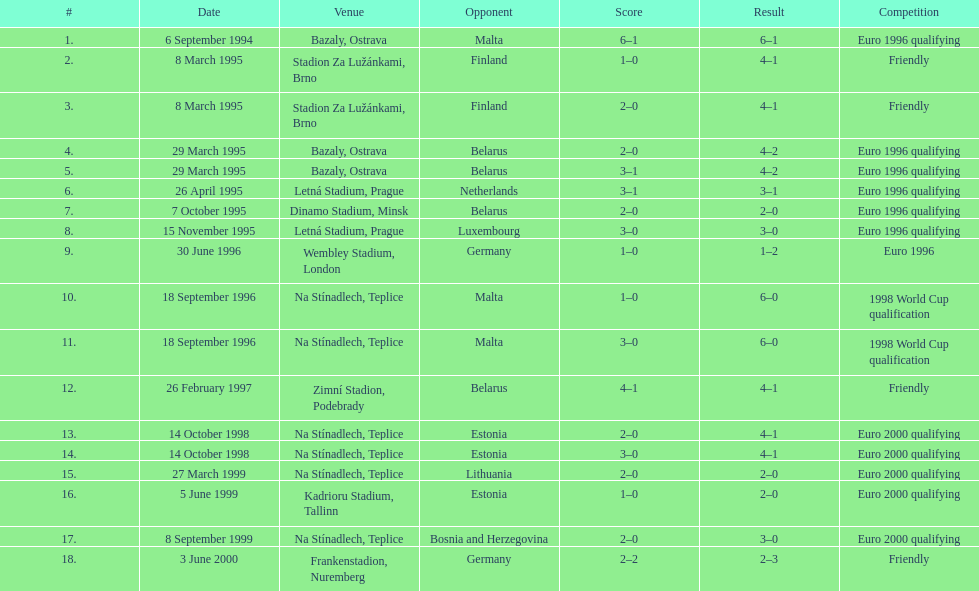How many euro 2000 qualifying competitions are listed? 4. 